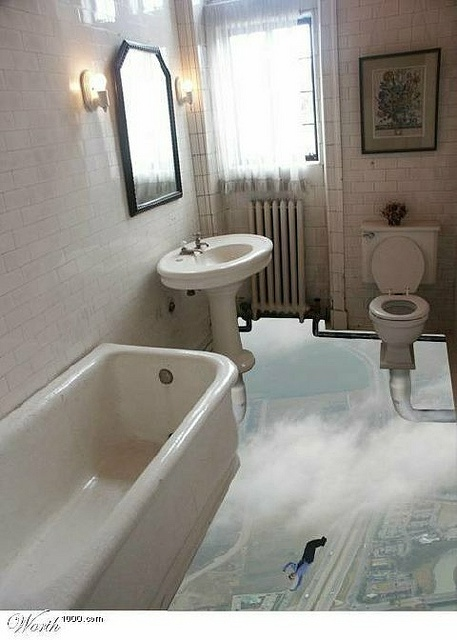Describe the objects in this image and their specific colors. I can see toilet in gray and black tones, sink in gray, lightgray, and darkgray tones, and people in gray, black, and darkgray tones in this image. 